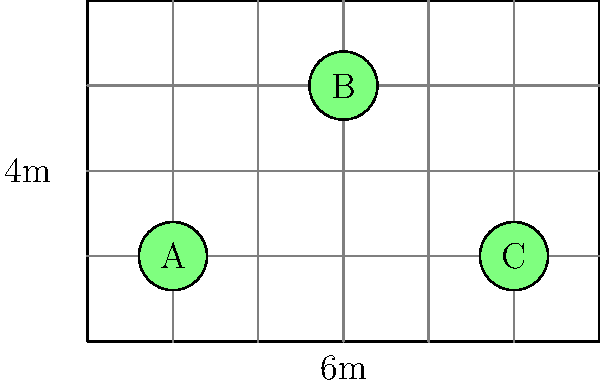In the solar energy storage unit shown above (6m x 4m), three batteries (A, B, and C) need to be placed to optimize energy distribution. The ideal arrangement maximizes the minimum distance between any two batteries. What is the optimal placement of the batteries to achieve this, and what is the resulting minimum distance between any two batteries? To optimize the placement of batteries in the solar energy storage unit, we need to follow these steps:

1. Understand the objective: Maximize the minimum distance between any two batteries.

2. Analyze the current arrangement:
   - Battery A: (1,1)
   - Battery B: (3,3)
   - Battery C: (5,1)

3. Calculate the distances between current battery positions:
   - A to B: $\sqrt{(3-1)^2 + (3-1)^2} = 2\sqrt{2} \approx 2.83$ m
   - A to C: $\sqrt{(5-1)^2 + (1-1)^2} = 4$ m
   - B to C: $\sqrt{(5-3)^2 + (1-3)^2} = 2\sqrt{2} \approx 2.83$ m

4. Identify the optimal arrangement:
   - Place batteries at three corners of the storage unit
   - New positions: (0,0), (6,0), (3,4)

5. Calculate the new distances:
   - (0,0) to (6,0): 6 m
   - (0,0) to (3,4): $\sqrt{3^2 + 4^2} = 5$ m
   - (6,0) to (3,4): $\sqrt{3^2 + 4^2} = 5$ m

6. Verify the improvement:
   - Minimum distance in original arrangement: $2\sqrt{2} \approx 2.83$ m
   - Minimum distance in optimal arrangement: 5 m

The optimal arrangement significantly increases the minimum distance between batteries, improving energy distribution efficiency.
Answer: Optimal placement: (0,0), (6,0), (3,4); Minimum distance: 5 m 